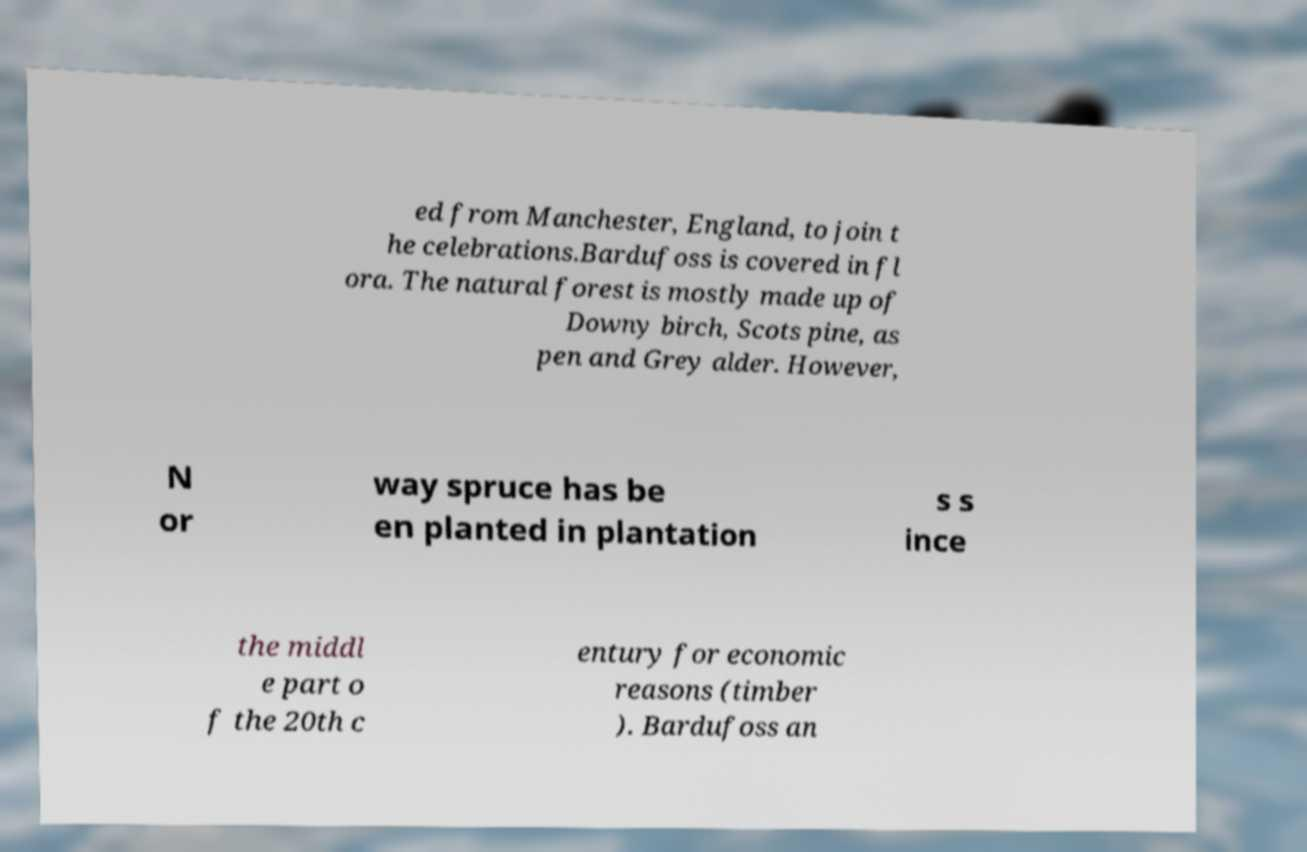Could you extract and type out the text from this image? ed from Manchester, England, to join t he celebrations.Bardufoss is covered in fl ora. The natural forest is mostly made up of Downy birch, Scots pine, as pen and Grey alder. However, N or way spruce has be en planted in plantation s s ince the middl e part o f the 20th c entury for economic reasons (timber ). Bardufoss an 